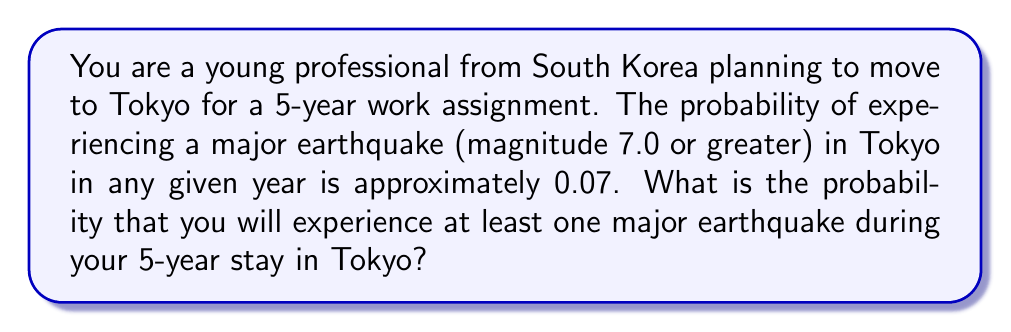Help me with this question. To solve this problem, we'll use the concept of complementary events and the probability of independent events.

1) Let's define our events:
   A: Experiencing at least one major earthquake in 5 years
   A': Not experiencing any major earthquakes in 5 years

2) We're looking for P(A), but it's easier to calculate P(A') first.

3) The probability of not experiencing a major earthquake in one year is:
   $P(\text{no earthquake in 1 year}) = 1 - 0.07 = 0.93$

4) For all 5 years to be earthquake-free, we need this to happen 5 times independently. The probability of independent events occurring together is the product of their individual probabilities:

   $P(A') = 0.93^5 = 0.6957$ (rounded to 4 decimal places)

5) Since A and A' are complementary events, their probabilities sum to 1:
   $P(A) + P(A') = 1$

6) Therefore:
   $P(A) = 1 - P(A') = 1 - 0.6957 = 0.3043$

Thus, the probability of experiencing at least one major earthquake during your 5-year stay in Tokyo is approximately 0.3043 or 30.43%.
Answer: The probability of experiencing at least one major earthquake during a 5-year stay in Tokyo is approximately $0.3043$ or $30.43\%$. 